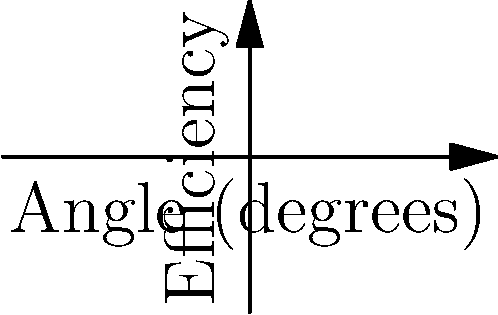In a patent infringement case, you're presented with efficiency data for a new solar panel design compared to an ideal panel. The graph shows efficiency as a function of light incident angle. If the patented design claims to maintain 80% efficiency of the ideal panel across all angles, at what angle does the patented design's efficiency drop below the claimed performance relative to the ideal panel? To solve this problem, we need to follow these steps:

1) The ideal panel's efficiency is represented by the function $f(\theta) = \cos(\theta)$, where $\theta$ is the incident angle.

2) The patented panel's efficiency is represented by $g(\theta) = 0.8\cos(\theta)$.

3) The claim states that the patented design maintains 80% efficiency of the ideal panel across all angles. This means we need to find where:

   $g(\theta) < 0.8f(\theta)$

4) Substituting our functions:

   $0.8\cos(\theta) < 0.8\cos(\theta)$

5) This inequality is never true for any angle $\theta$, as both sides are always equal.

6) Therefore, the patented design always maintains exactly 80% of the ideal panel's efficiency at every angle, never dropping below this claimed performance.
Answer: The efficiency never drops below the claimed 80% of the ideal panel. 